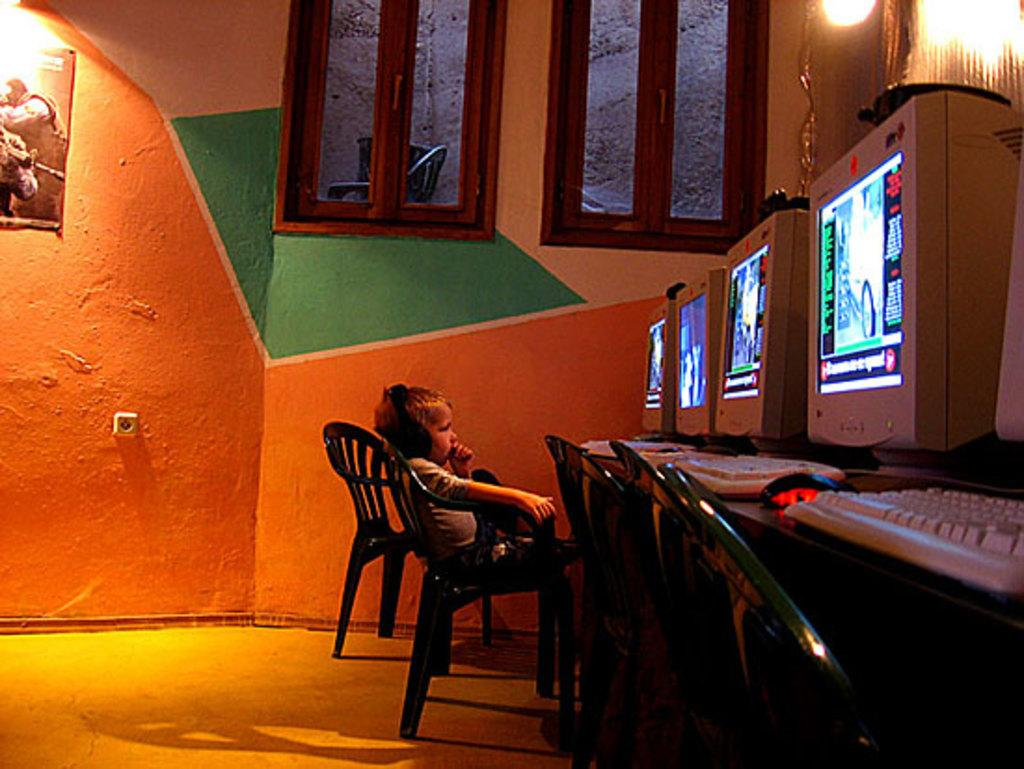What is the kid doing in the image? The kid is sitting on a chair in the image. What is the kid wearing on their head? The kid is wearing a wired headset in the image. What can be seen on the table in the image? There are monitors, keyboards, and a mouse on the table in the image. How many chairs are visible in the room? There are chairs in the room, but the exact number is not specified in the facts. What is on the wall in the image? There is a poster on the wall in the image. What type of lighting is present in the room? There are lights in the room in the image. What is visible under the chairs and tables? There is a floor visible in the image. Can you see a receipt on the table in the image? There is no mention of a receipt in the facts provided, so it cannot be determined if one is present in the image. 